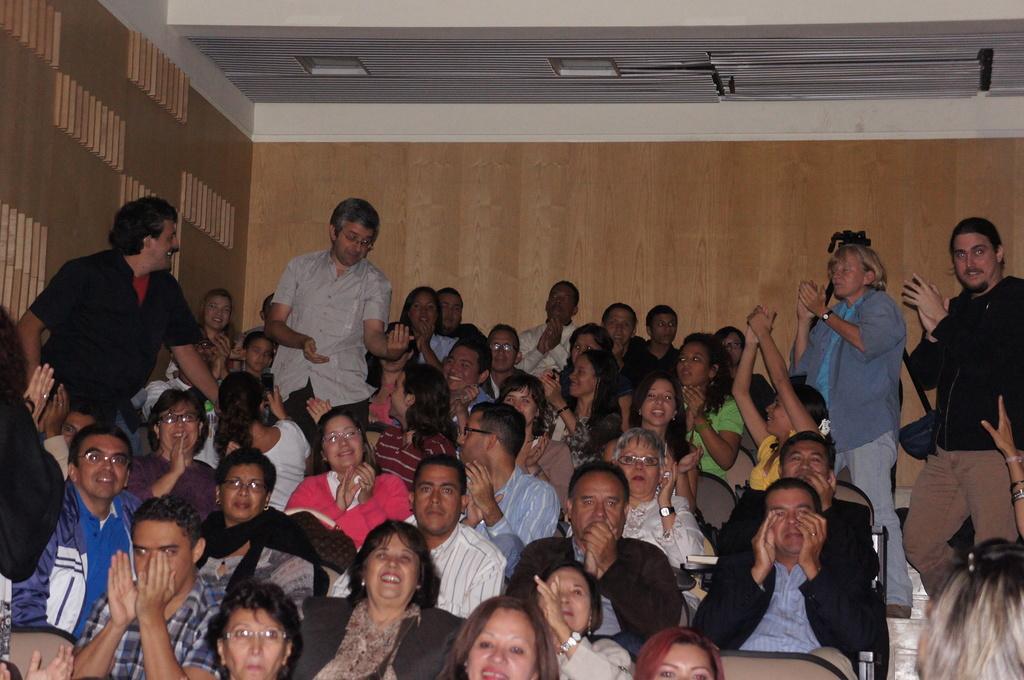Can you describe this image briefly? In this image we can see few people, some of them are sitting on the chairs and some of them are standing, there are lights to the ceiling and an object behind a person. 